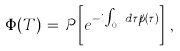<formula> <loc_0><loc_0><loc_500><loc_500>\Phi ( T ) \, = \, { \mathcal { P } } \left [ e ^ { - i \int _ { 0 } ^ { T } d \tau { \not p } ( \tau ) } \right ] \, ,</formula> 